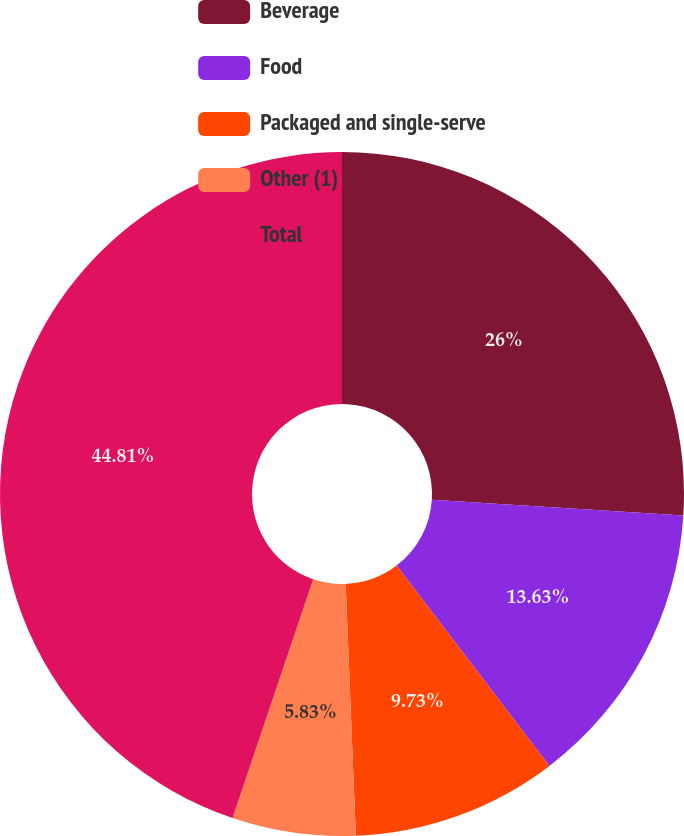<chart> <loc_0><loc_0><loc_500><loc_500><pie_chart><fcel>Beverage<fcel>Food<fcel>Packaged and single-serve<fcel>Other (1)<fcel>Total<nl><fcel>26.0%<fcel>13.63%<fcel>9.73%<fcel>5.83%<fcel>44.82%<nl></chart> 